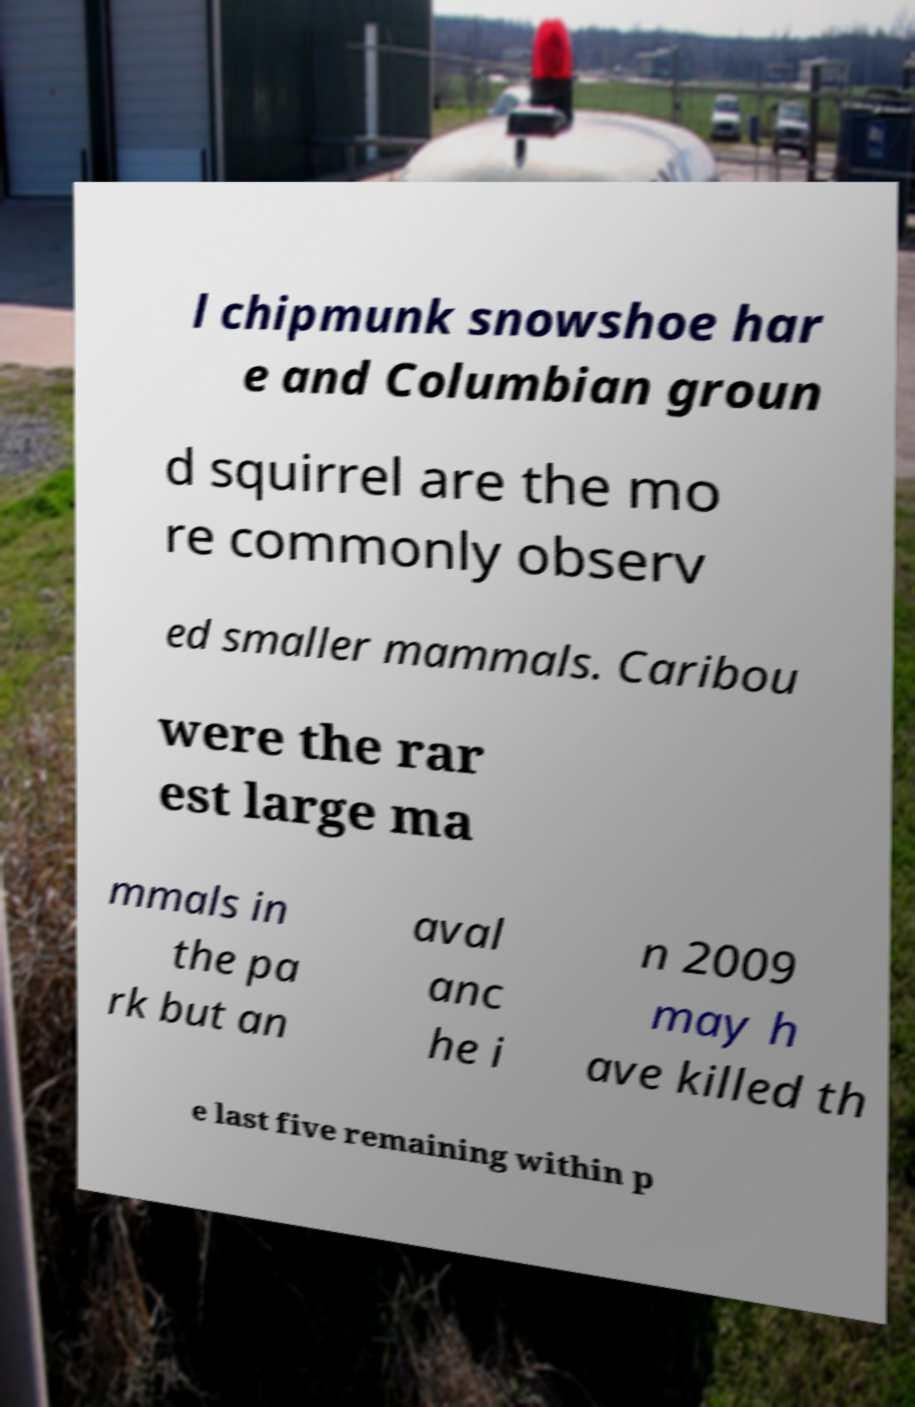For documentation purposes, I need the text within this image transcribed. Could you provide that? l chipmunk snowshoe har e and Columbian groun d squirrel are the mo re commonly observ ed smaller mammals. Caribou were the rar est large ma mmals in the pa rk but an aval anc he i n 2009 may h ave killed th e last five remaining within p 